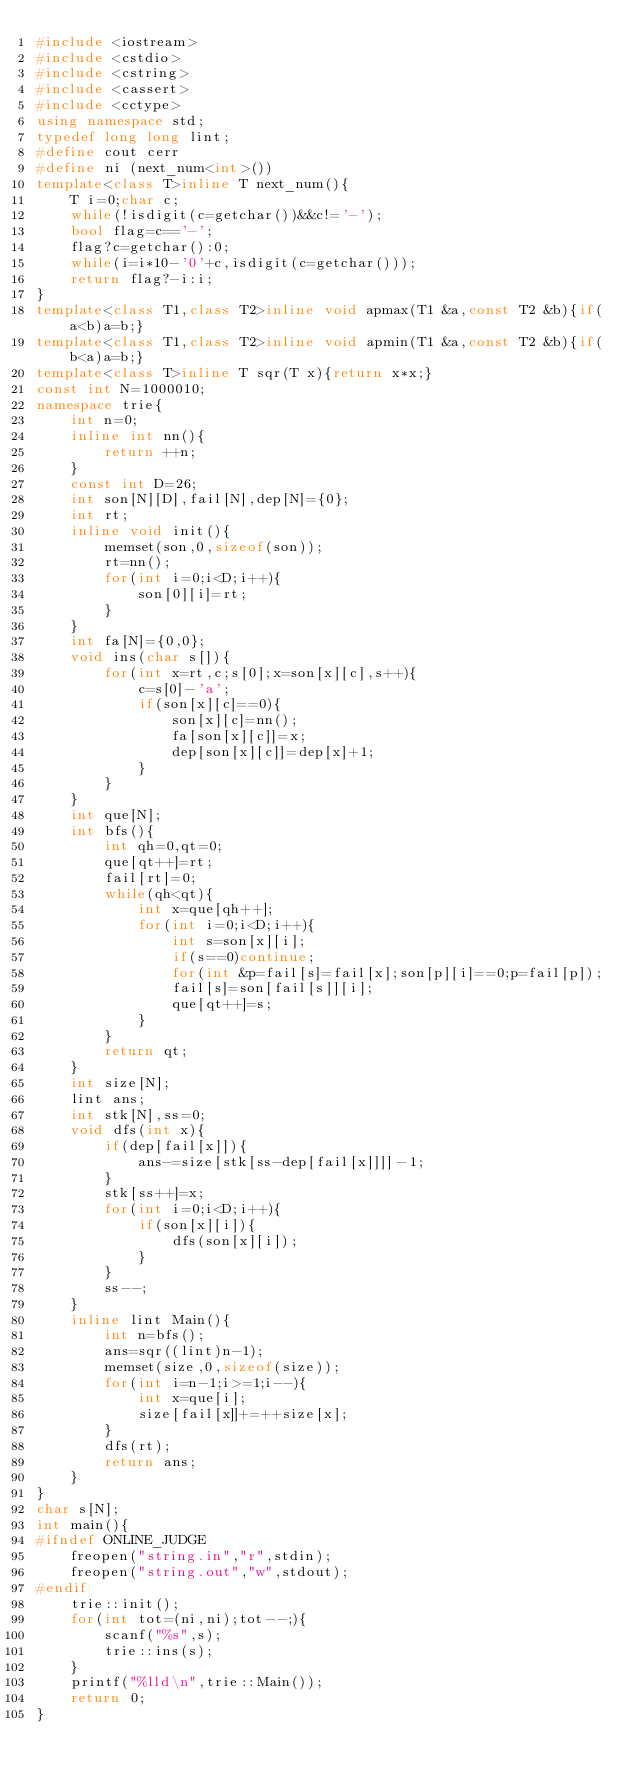<code> <loc_0><loc_0><loc_500><loc_500><_C++_>#include <iostream>
#include <cstdio>
#include <cstring>
#include <cassert>
#include <cctype>
using namespace std;
typedef long long lint;
#define cout cerr
#define ni (next_num<int>())
template<class T>inline T next_num(){
	T i=0;char c;
	while(!isdigit(c=getchar())&&c!='-');
	bool flag=c=='-';
	flag?c=getchar():0;
	while(i=i*10-'0'+c,isdigit(c=getchar()));
	return flag?-i:i;
}
template<class T1,class T2>inline void apmax(T1 &a,const T2 &b){if(a<b)a=b;}
template<class T1,class T2>inline void apmin(T1 &a,const T2 &b){if(b<a)a=b;}
template<class T>inline T sqr(T x){return x*x;}
const int N=1000010;
namespace trie{
	int n=0;
	inline int nn(){
		return ++n;
	}
	const int D=26;
	int son[N][D],fail[N],dep[N]={0};
	int rt;
	inline void init(){
		memset(son,0,sizeof(son));
		rt=nn();
		for(int i=0;i<D;i++){
			son[0][i]=rt;
		}
	}
	int fa[N]={0,0};
	void ins(char s[]){
		for(int x=rt,c;s[0];x=son[x][c],s++){
			c=s[0]-'a';
			if(son[x][c]==0){
				son[x][c]=nn();
				fa[son[x][c]]=x;
				dep[son[x][c]]=dep[x]+1;
			}
		}
	}
	int que[N];
	int bfs(){
		int qh=0,qt=0;
		que[qt++]=rt;
		fail[rt]=0;
		while(qh<qt){
			int x=que[qh++];
			for(int i=0;i<D;i++){
				int s=son[x][i];
				if(s==0)continue;
				for(int &p=fail[s]=fail[x];son[p][i]==0;p=fail[p]);
				fail[s]=son[fail[s]][i];
				que[qt++]=s;
			}
		}
		return qt;
	}
	int size[N];
	lint ans;
	int stk[N],ss=0;
	void dfs(int x){
		if(dep[fail[x]]){
			ans-=size[stk[ss-dep[fail[x]]]]-1;
		}
		stk[ss++]=x;
		for(int i=0;i<D;i++){
			if(son[x][i]){
				dfs(son[x][i]);
			}
		}
		ss--;
	}
	inline lint Main(){
		int n=bfs();
		ans=sqr((lint)n-1);
		memset(size,0,sizeof(size));
		for(int i=n-1;i>=1;i--){
			int x=que[i];
			size[fail[x]]+=++size[x];
		}
		dfs(rt);
		return ans;
	}
}
char s[N];
int main(){
#ifndef ONLINE_JUDGE
	freopen("string.in","r",stdin);
	freopen("string.out","w",stdout);
#endif
	trie::init();
	for(int tot=(ni,ni);tot--;){
		scanf("%s",s);
		trie::ins(s);
	}
	printf("%lld\n",trie::Main());
	return 0;
}
</code> 